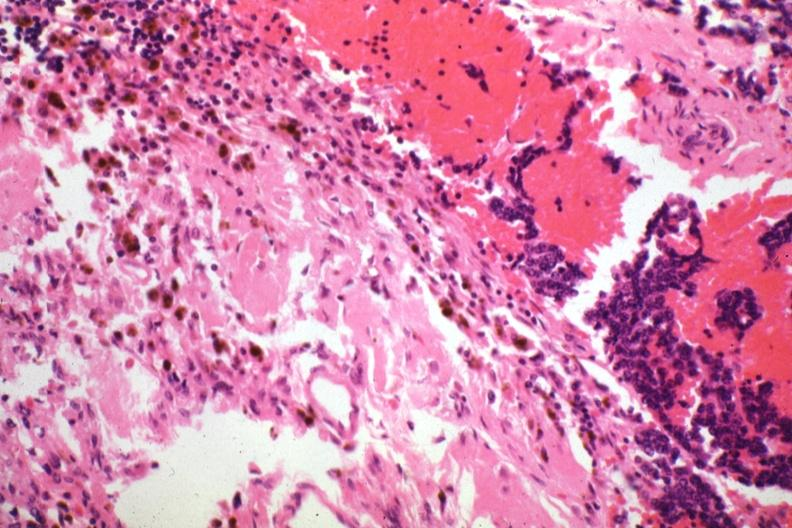s aorta present?
Answer the question using a single word or phrase. No 